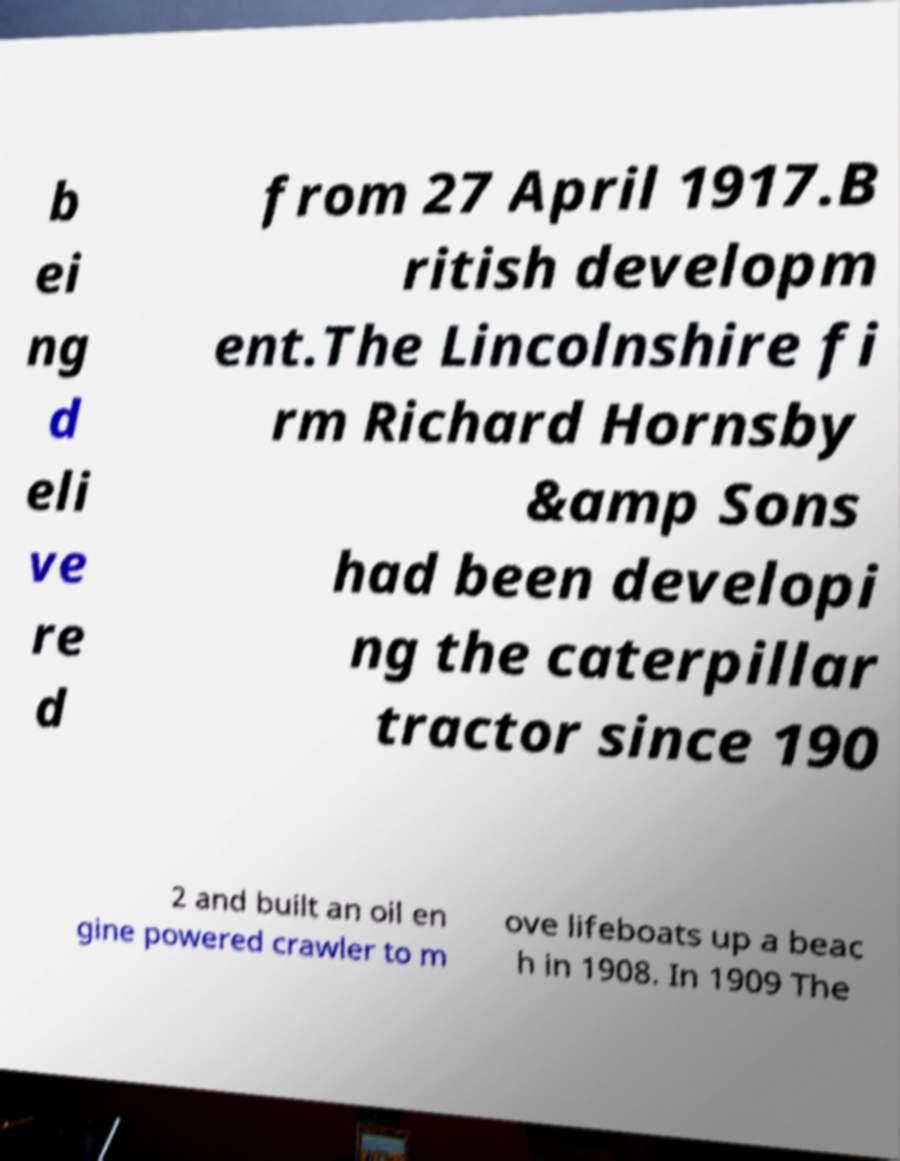Could you assist in decoding the text presented in this image and type it out clearly? b ei ng d eli ve re d from 27 April 1917.B ritish developm ent.The Lincolnshire fi rm Richard Hornsby &amp Sons had been developi ng the caterpillar tractor since 190 2 and built an oil en gine powered crawler to m ove lifeboats up a beac h in 1908. In 1909 The 